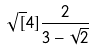<formula> <loc_0><loc_0><loc_500><loc_500>\sqrt { [ } 4 ] { \frac { 2 } { 3 - \sqrt { 2 } } }</formula> 